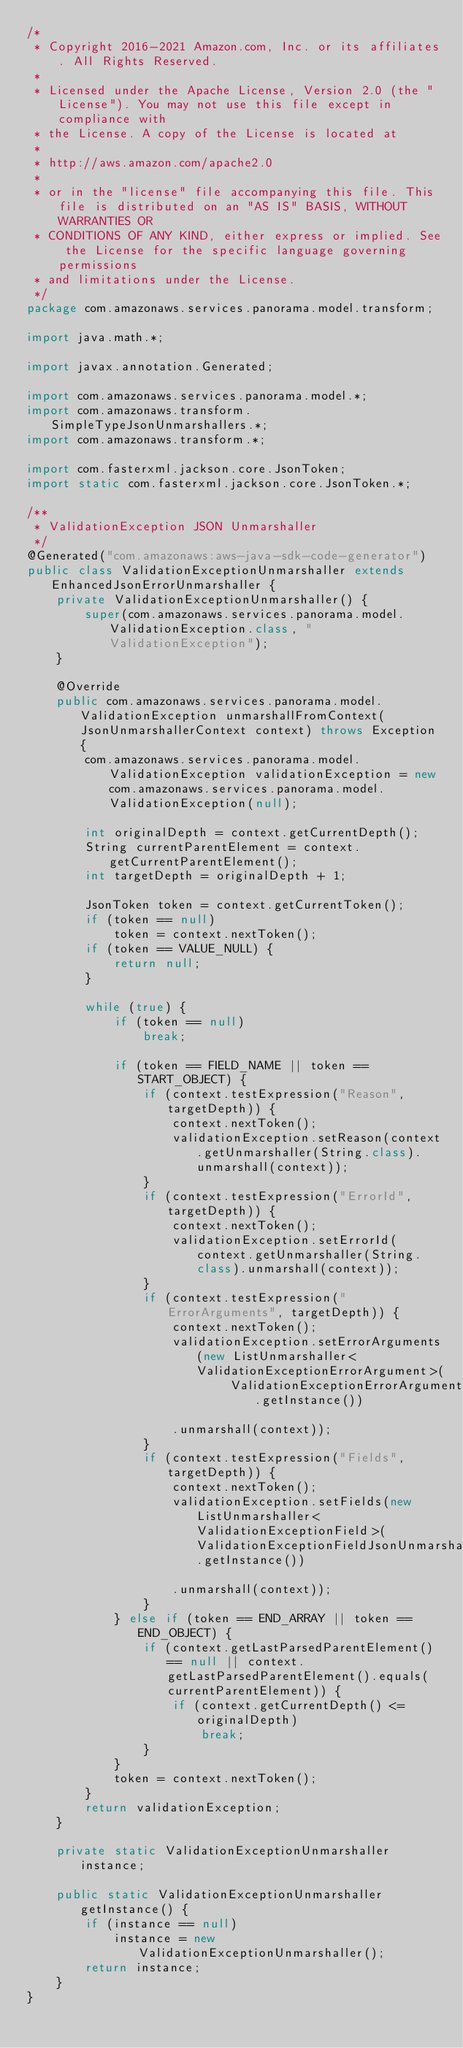Convert code to text. <code><loc_0><loc_0><loc_500><loc_500><_Java_>/*
 * Copyright 2016-2021 Amazon.com, Inc. or its affiliates. All Rights Reserved.
 * 
 * Licensed under the Apache License, Version 2.0 (the "License"). You may not use this file except in compliance with
 * the License. A copy of the License is located at
 * 
 * http://aws.amazon.com/apache2.0
 * 
 * or in the "license" file accompanying this file. This file is distributed on an "AS IS" BASIS, WITHOUT WARRANTIES OR
 * CONDITIONS OF ANY KIND, either express or implied. See the License for the specific language governing permissions
 * and limitations under the License.
 */
package com.amazonaws.services.panorama.model.transform;

import java.math.*;

import javax.annotation.Generated;

import com.amazonaws.services.panorama.model.*;
import com.amazonaws.transform.SimpleTypeJsonUnmarshallers.*;
import com.amazonaws.transform.*;

import com.fasterxml.jackson.core.JsonToken;
import static com.fasterxml.jackson.core.JsonToken.*;

/**
 * ValidationException JSON Unmarshaller
 */
@Generated("com.amazonaws:aws-java-sdk-code-generator")
public class ValidationExceptionUnmarshaller extends EnhancedJsonErrorUnmarshaller {
    private ValidationExceptionUnmarshaller() {
        super(com.amazonaws.services.panorama.model.ValidationException.class, "ValidationException");
    }

    @Override
    public com.amazonaws.services.panorama.model.ValidationException unmarshallFromContext(JsonUnmarshallerContext context) throws Exception {
        com.amazonaws.services.panorama.model.ValidationException validationException = new com.amazonaws.services.panorama.model.ValidationException(null);

        int originalDepth = context.getCurrentDepth();
        String currentParentElement = context.getCurrentParentElement();
        int targetDepth = originalDepth + 1;

        JsonToken token = context.getCurrentToken();
        if (token == null)
            token = context.nextToken();
        if (token == VALUE_NULL) {
            return null;
        }

        while (true) {
            if (token == null)
                break;

            if (token == FIELD_NAME || token == START_OBJECT) {
                if (context.testExpression("Reason", targetDepth)) {
                    context.nextToken();
                    validationException.setReason(context.getUnmarshaller(String.class).unmarshall(context));
                }
                if (context.testExpression("ErrorId", targetDepth)) {
                    context.nextToken();
                    validationException.setErrorId(context.getUnmarshaller(String.class).unmarshall(context));
                }
                if (context.testExpression("ErrorArguments", targetDepth)) {
                    context.nextToken();
                    validationException.setErrorArguments(new ListUnmarshaller<ValidationExceptionErrorArgument>(
                            ValidationExceptionErrorArgumentJsonUnmarshaller.getInstance())

                    .unmarshall(context));
                }
                if (context.testExpression("Fields", targetDepth)) {
                    context.nextToken();
                    validationException.setFields(new ListUnmarshaller<ValidationExceptionField>(ValidationExceptionFieldJsonUnmarshaller.getInstance())

                    .unmarshall(context));
                }
            } else if (token == END_ARRAY || token == END_OBJECT) {
                if (context.getLastParsedParentElement() == null || context.getLastParsedParentElement().equals(currentParentElement)) {
                    if (context.getCurrentDepth() <= originalDepth)
                        break;
                }
            }
            token = context.nextToken();
        }
        return validationException;
    }

    private static ValidationExceptionUnmarshaller instance;

    public static ValidationExceptionUnmarshaller getInstance() {
        if (instance == null)
            instance = new ValidationExceptionUnmarshaller();
        return instance;
    }
}
</code> 